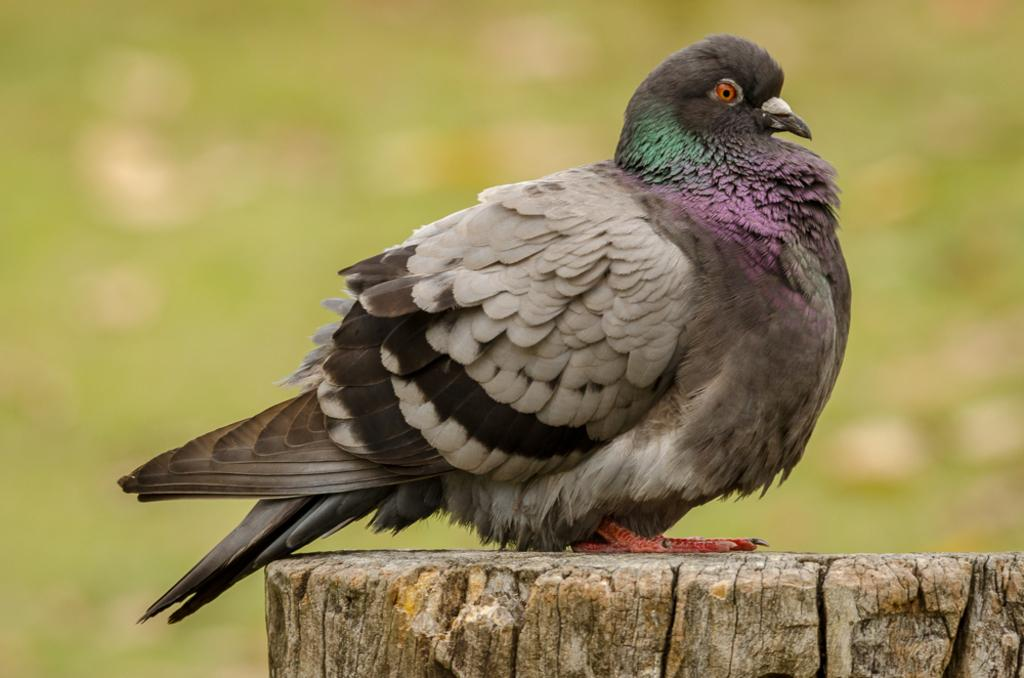What type of animal is in the image? There is a pigeon in the image. Where is the pigeon located? The pigeon is sitting on a wooden trunk. Can you describe the background of the image? The background of the image is blurred. What color is the scarf that the pigeon is wearing in the image? There is no scarf present in the image, as pigeons do not wear clothing. 